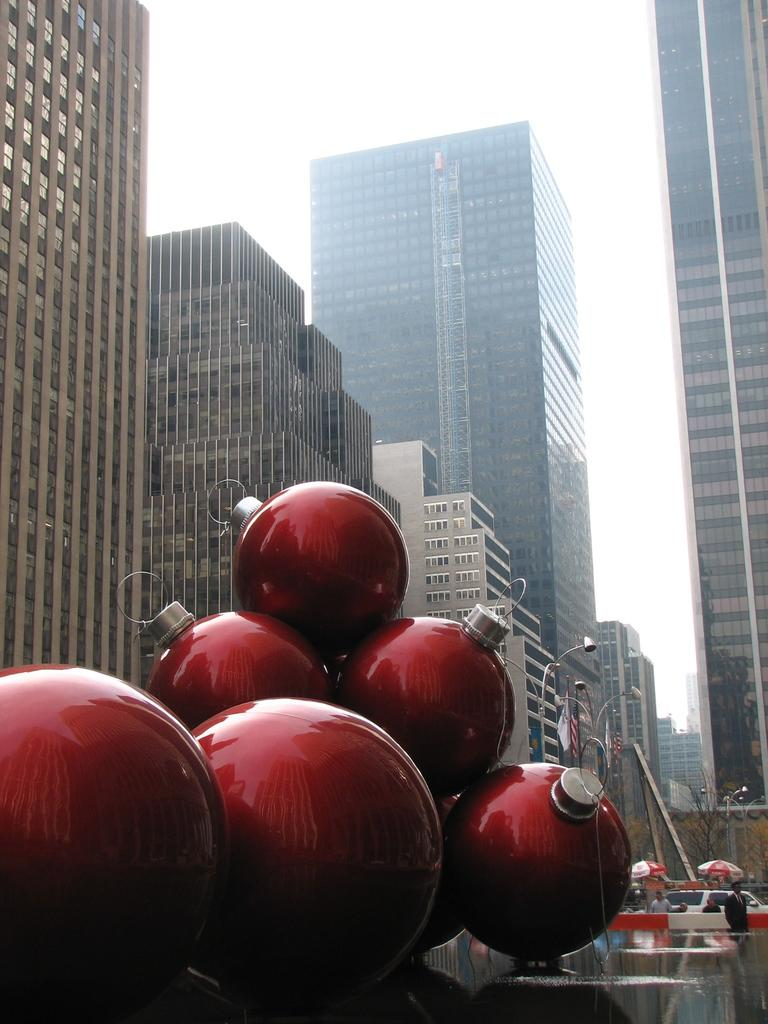What type of structures can be seen in the image? There are buildings in the image. What color is present on some objects in the image? There are red color objects in the image. What type of lighting is present in the image? There are street lights in the image. What can be seen in the background of the image? There are people and at least one vehicle in the background of the image, as well as the sky. What letter is being delivered to the people in the image? There is no letter being delivered in the image; it only shows buildings, red objects, street lights, people, a vehicle, and the sky. 